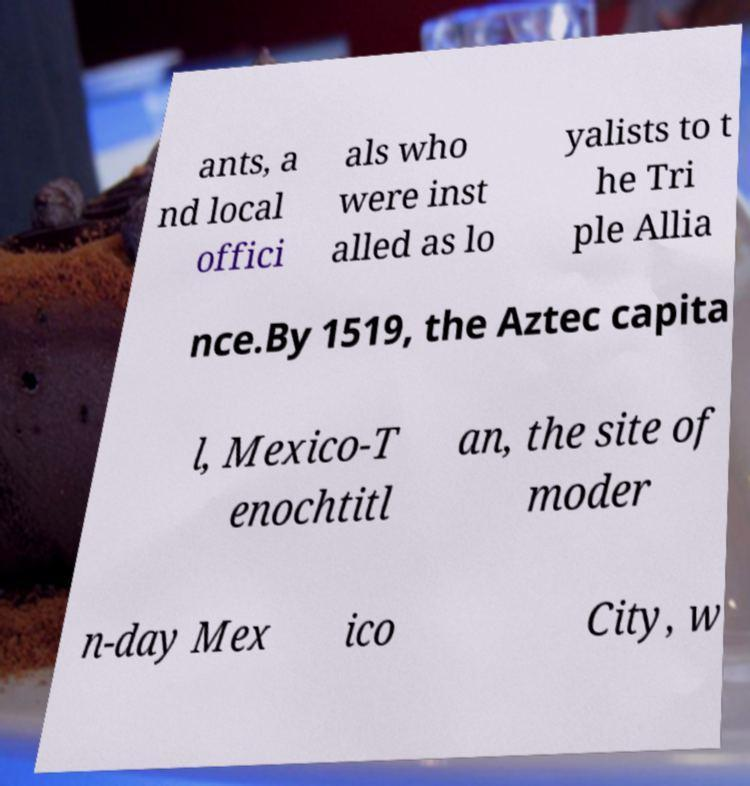Could you assist in decoding the text presented in this image and type it out clearly? ants, a nd local offici als who were inst alled as lo yalists to t he Tri ple Allia nce.By 1519, the Aztec capita l, Mexico-T enochtitl an, the site of moder n-day Mex ico City, w 